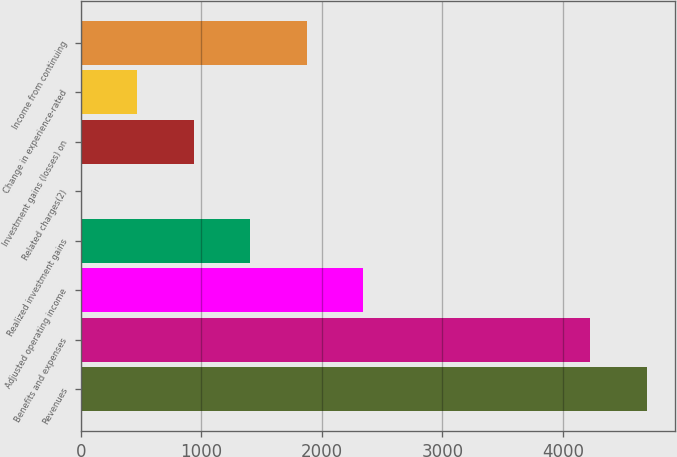Convert chart. <chart><loc_0><loc_0><loc_500><loc_500><bar_chart><fcel>Revenues<fcel>Benefits and expenses<fcel>Adjusted operating income<fcel>Realized investment gains<fcel>Related charges(2)<fcel>Investment gains (losses) on<fcel>Change in experience-rated<fcel>Income from continuing<nl><fcel>4694.1<fcel>4226<fcel>2341.5<fcel>1405.3<fcel>1<fcel>937.2<fcel>469.1<fcel>1873.4<nl></chart> 